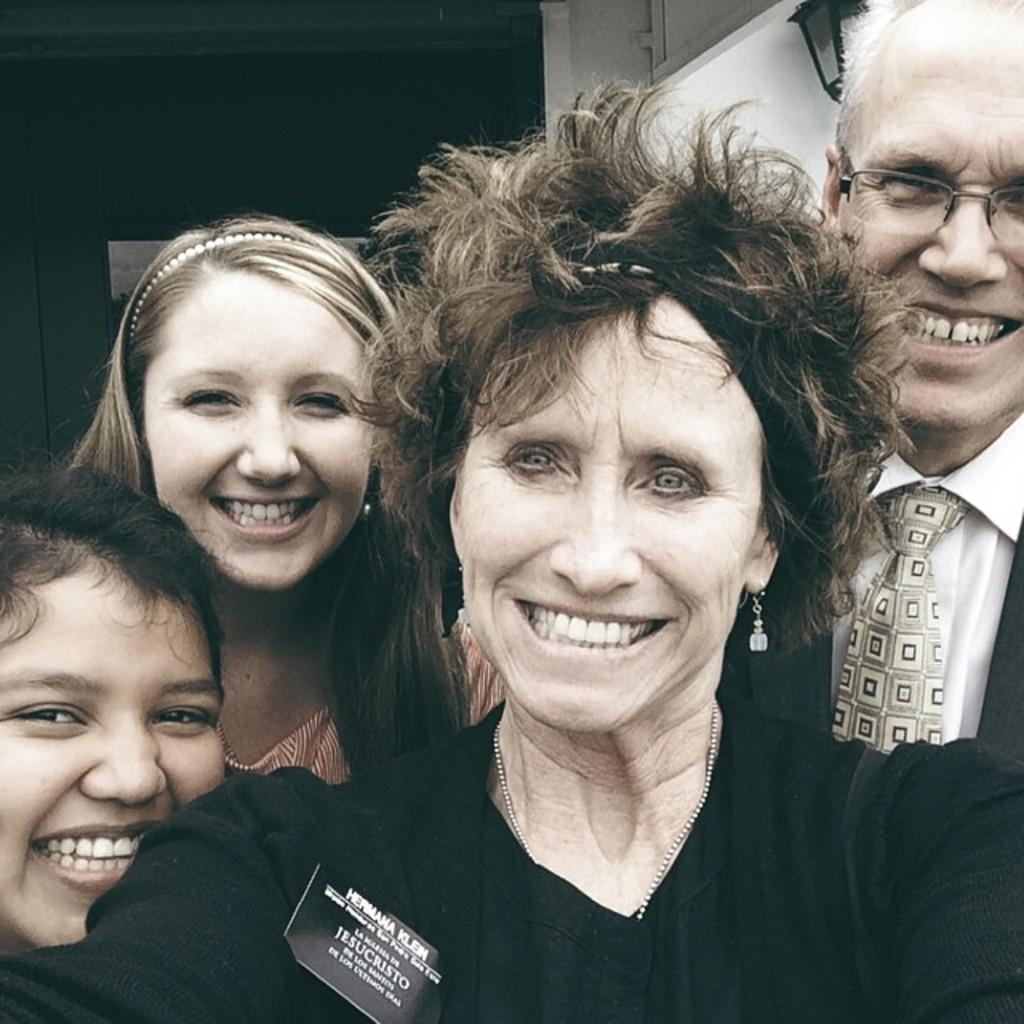What is happening in the image involving the group of people? The people in the image are smiling, suggesting a positive or happy situation. Can you describe the man on the right side of the image? The man on the right side of the image is wearing spectacles. What can be seen in the background of the image? There is a light visible in the background of the image. Can you describe the frog that is jumping on the bed in the image? There is no frog present in the image, nor is there a bed. 